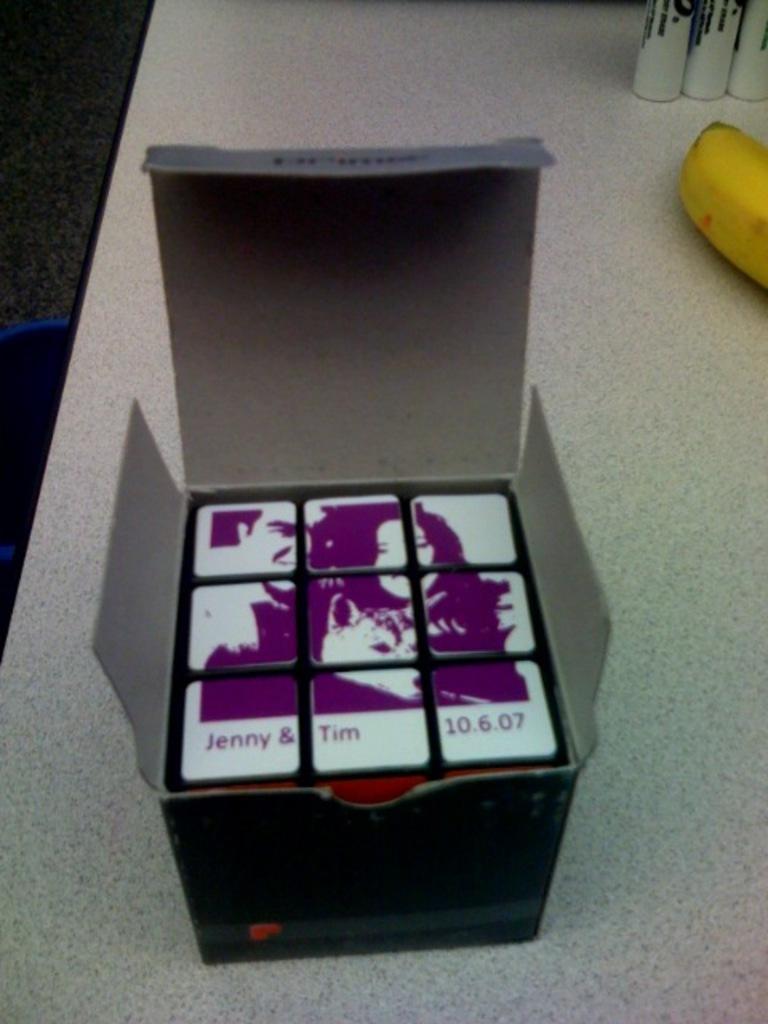Please provide a concise description of this image. In the foreground of this image, there is a cube in a cardboard box which is placed on a table and we can also see a banana and few objects on the table. On the left, there is the floor and a blue object. 